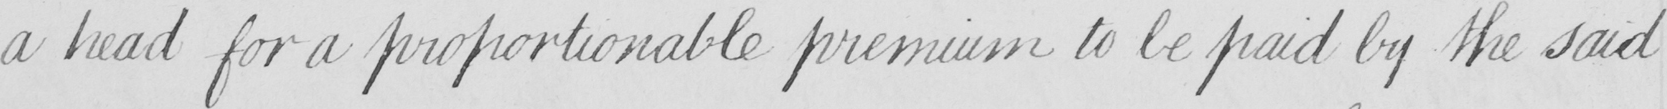Can you tell me what this handwritten text says? a head for a proportionable premium to be paid by the said 